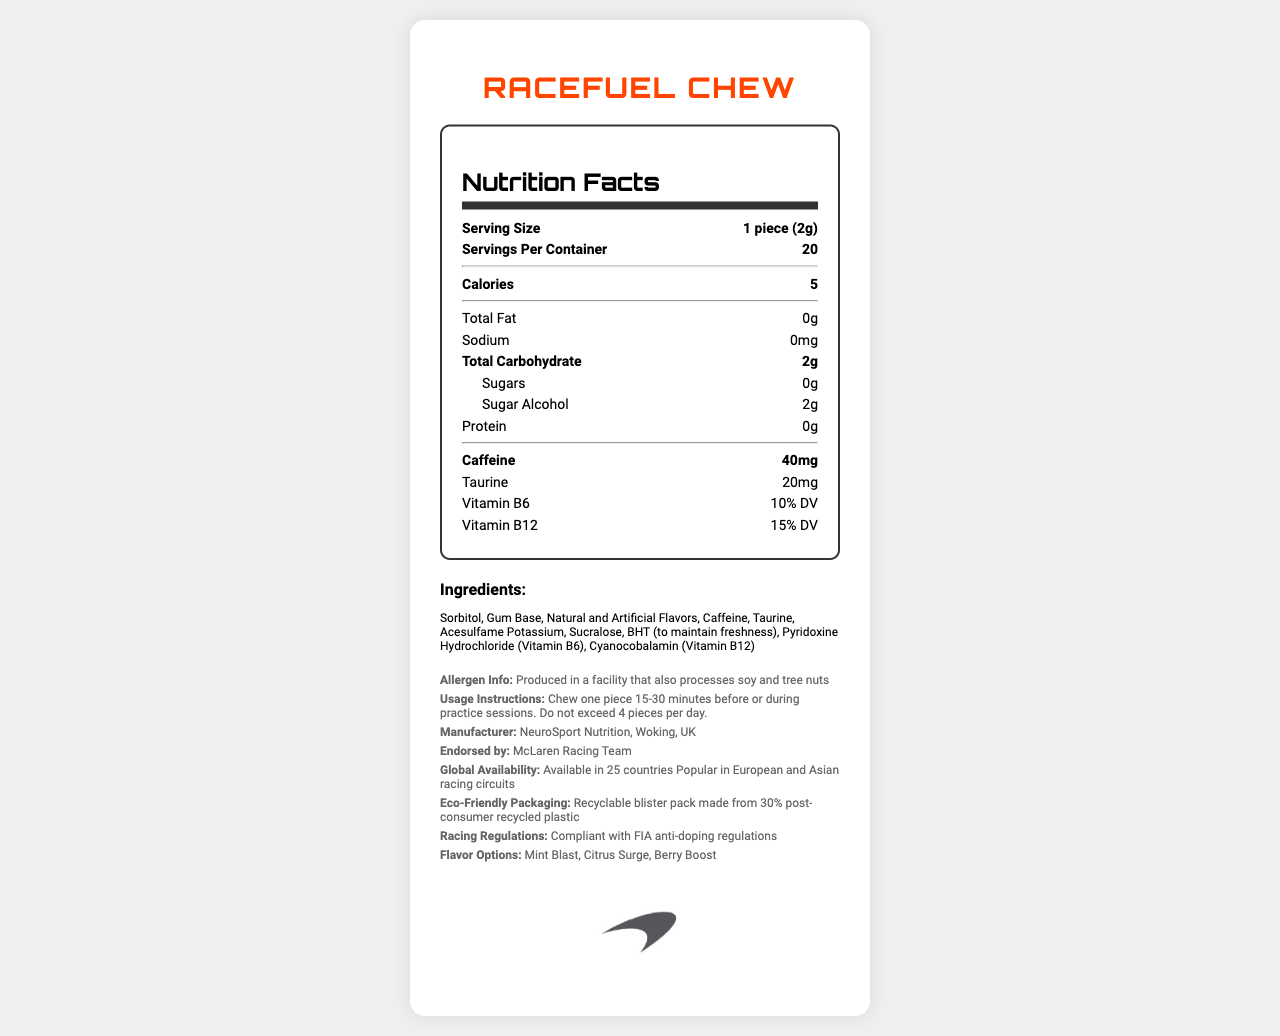what is the serving size of RaceFuel Chew? The serving size information is listed near the top of the nutrition label under "Serving Size".
Answer: 1 piece (2g) how many servings per container does RaceFuel Chew have? The number of servings per container is mentioned right below the serving size on the nutrition label.
Answer: 20 how many calories are in one serving of RaceFuel Chew? The number of calories per serving is highlighted in bold on the nutrition label.
Answer: 5 how much caffeine does one piece of RaceFuel Chew contain? The caffeine content per serving is shown in bold on the nutrition label under the nutritional information.
Answer: 40mg what is the daily value percentage of vitamin B12 in RaceFuel Chew? The daily value percentage for vitamin B12 is listed in the nutritional information section.
Answer: 15% DV what ingredients are used in RaceFuel Chew? The ingredients are detailed under the "Ingredients" section.
Answer: Sorbitol, Gum Base, Natural and Artificial Flavors, Caffeine, Taurine, Acesulfame Potassium, Sucralose, BHT (to maintain freshness), Pyridoxine Hydrochloride (Vitamin B6), Cyanocobalamin (Vitamin B12) where is RaceFuel Chew manufactured? The manufacturing location is mentioned under "Manufacturer" in the additional info section.
Answer: Woking, UK how many pieces of RaceFuel Chew should be consumed daily as a maximum? The usage instructions state not to exceed more than 4 pieces per day.
Answer: 4 pieces what team endorses RaceFuel Chew? The endorsement by the McLaren Racing Team is noted in the additional info section.
Answer: McLaren Racing Team which of the following flavors is a flavor option for RaceFuel Chew? A. Vanilla Rush B. Mint Blast C. Tropical Twist The flavor options mentioned in the document include Mint Blast, Citrus Surge, and Berry Boost.
Answer: B what is the total carbohydrate content in one serving of RaceFuel Chew? A. 1g B. 2g C. 5g D. 10g According to the nutritional label, one serving of RaceFuel Chew contains 2g of total carbohydrates.
Answer: B is RaceFuel Chew compliant with FIA anti-doping regulations? The document clearly states that RaceFuel Chew is compliant with FIA anti-doping regulations.
Answer: Yes summarize the main features and attributes of RaceFuel Chew described in the document This summary provides an overview of the product's nutritional facts, endorsers, usage instructions, ingredients, regulations compliance, and packaging information.
Answer: RaceFuel Chew is a caffeine-rich performance gum favored by Formula 1 drivers, endorsed by McLaren Racing Team. It comes in serving sizes of 1 piece (2g) and has 40mg of caffeine per piece. It contains 5 calories per serving and uses a blend of ingredients including sorbitol, caffeine, and vitamins B6 and B12. The product is compliant with FIA anti-doping regulations, produced in Woking, UK, and features recyclable packaging. It is available globally and popular in European and Asian racing circuits. Usage instructions recommend not exceeding four pieces per day. who is the specific driver that endorses RaceFuel Chew? The document says RaceFuel Chew is endorsed by the McLaren Racing Team but does not mention any specific driver.
Answer: Cannot be determined 